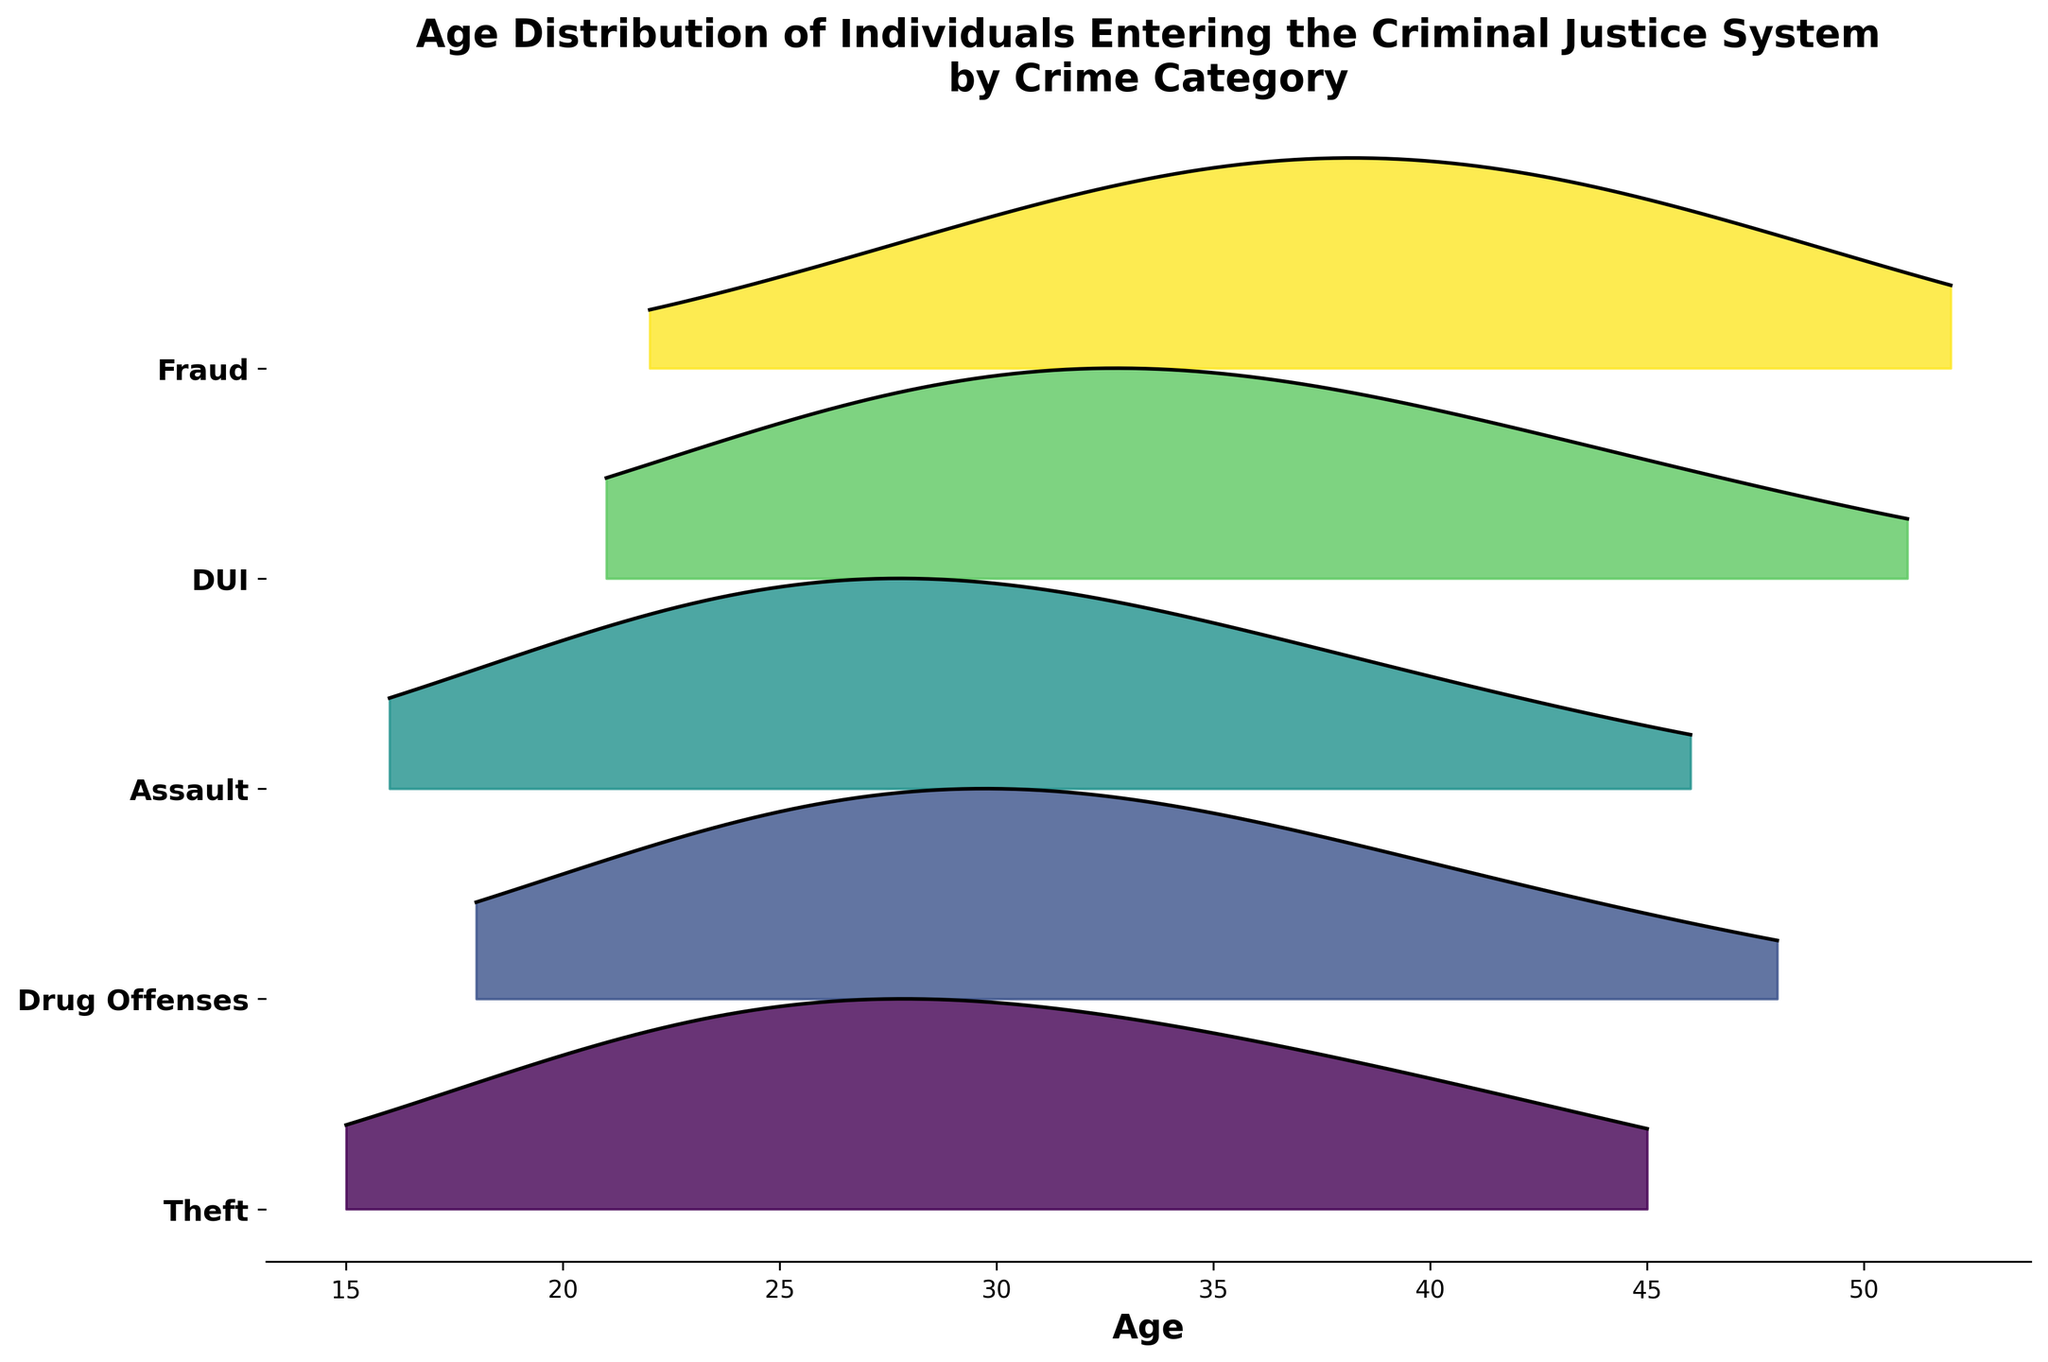What's the title of the figure? The title of the figure is usually placed at the top and summarizes the plot's content. This plot’s title clearly mentions what the visual represents.
Answer: Age Distribution of Individuals Entering the Criminal Justice System by Crime Category How is the y-axis labeled? The y-axis labels refer to the crime categories since each ridge line represents a different category.
Answer: Crime categories Which crime category shows the highest density for individuals around age 25? By examining the figure, we see that the peak of the density is highest for the category with a notable density value around the age of 25. Comparing across categories, we observe that "Theft" shows the highest density around this age.
Answer: Theft Which crime category has the widest age distribution? Looking at the spread of the density functions for each category on the x-axis, we identify the category where the ages span the widest range. "DUI" has an extensive age range from 21 to around 51 years.
Answer: DUI Do older individuals tend to enter the system for Fraud or Assault? By comparing the density peaks and distributions for "Fraud" and "Assault," Fraud shows a peak skewed towards older ages, while Assault peaks earlier. Therefore, older individuals are more associated with Fraud.
Answer: Fraud What's the peak density value for Drug Offenses? Observe the y-axis position for the "Drug Offenses" category and follow the density function to identify the highest peak value along the ridge line. The highest region for "Drug Offenses" is around 0.14.
Answer: 0.14 In which crime category are individuals around age 30 most represented? By looking at the figure around age 30 and checking which ridge line appears highest at that point, we conclude that DUI has the highest representation for individuals around age 30.
Answer: DUI Which category has the lowest maximum density? Compare peak densities of each ridge line. The category with the smallest peak is "Fraud," which peaks at 0.14, tied with "Drug Offenses". A detailed comparison shows the same max but lower than others like Theft or Assault.
Answer: Fraud Comparing Assault and Theft, which category has a higher density at age 16? By locating age 16 on the x-axis and comparing the vertical heights of the ridgeline plots for Assault and Theft at that age, we observe that Assault has a higher density at age 16.
Answer: Assault What is the age range for the highest density in DUI? By observing the DUI ridgeline plot and noting the age range where the density is highest, we find that it is between ages 26 and 36.
Answer: 26 to 36 